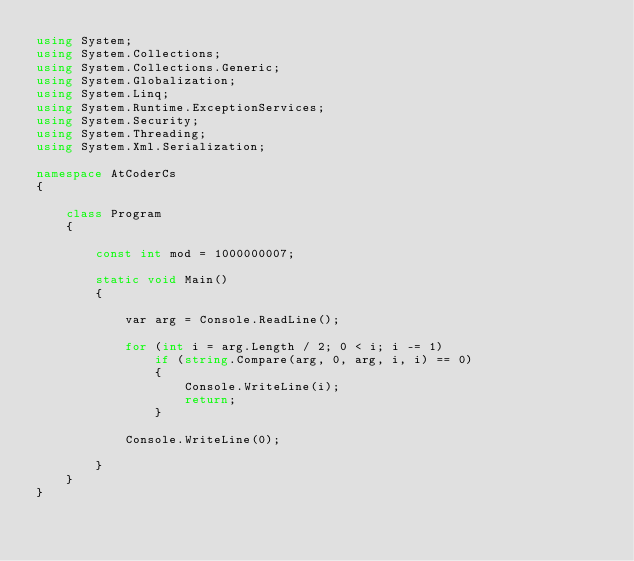<code> <loc_0><loc_0><loc_500><loc_500><_C#_>using System;
using System.Collections;
using System.Collections.Generic;
using System.Globalization;
using System.Linq;
using System.Runtime.ExceptionServices;
using System.Security;
using System.Threading;
using System.Xml.Serialization;

namespace AtCoderCs
{

    class Program
    {

        const int mod = 1000000007;

        static void Main()
        {

            var arg = Console.ReadLine();

            for (int i = arg.Length / 2; 0 < i; i -= 1)
                if (string.Compare(arg, 0, arg, i, i) == 0)
                {
                    Console.WriteLine(i);
                    return;
                }

            Console.WriteLine(0);

        }
    }
}
</code> 